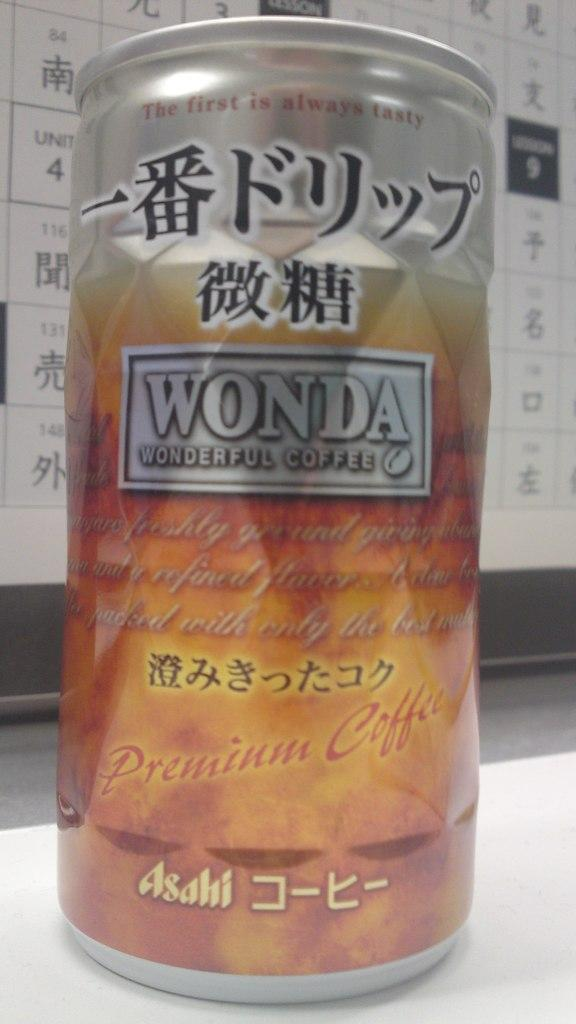<image>
Provide a brief description of the given image. A can of Wonda wonderful coffee in a silver box. 